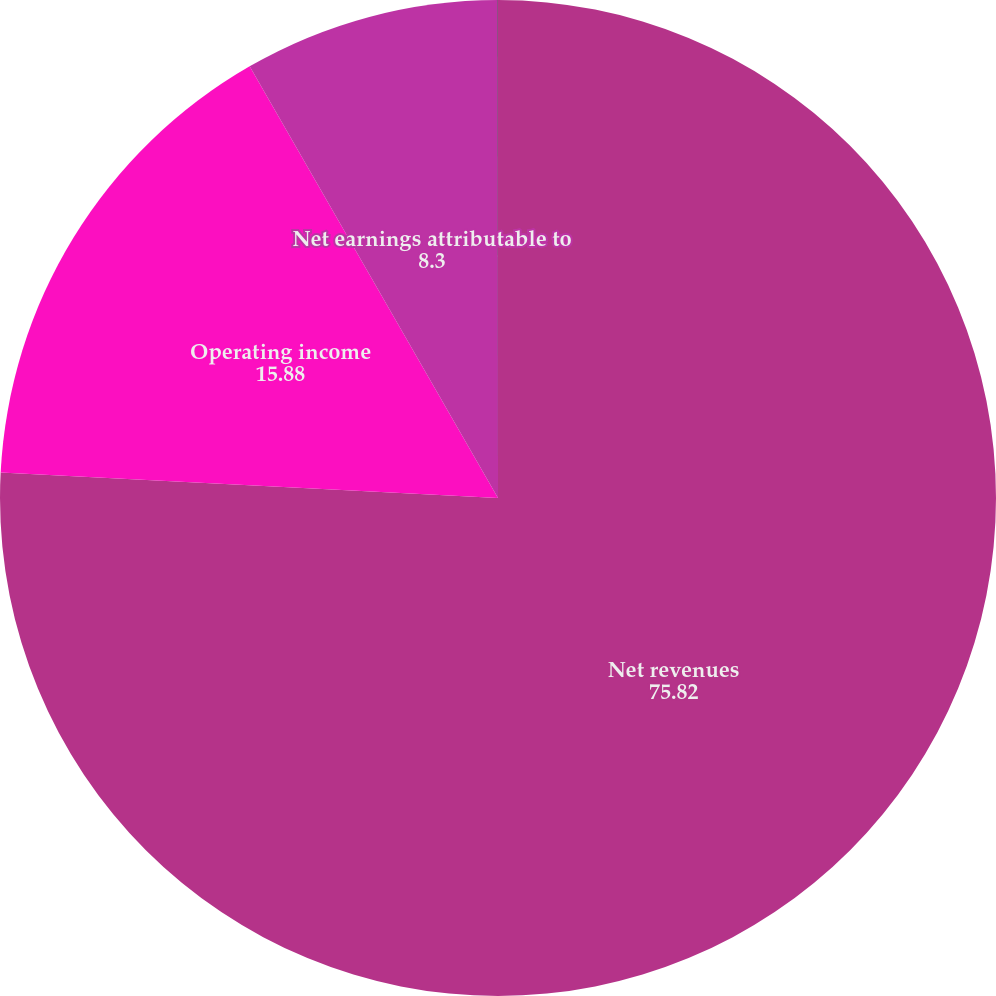<chart> <loc_0><loc_0><loc_500><loc_500><pie_chart><fcel>Net revenues<fcel>Operating income<fcel>Net earnings attributable to<fcel>EPS - diluted<nl><fcel>75.82%<fcel>15.88%<fcel>8.3%<fcel>0.01%<nl></chart> 